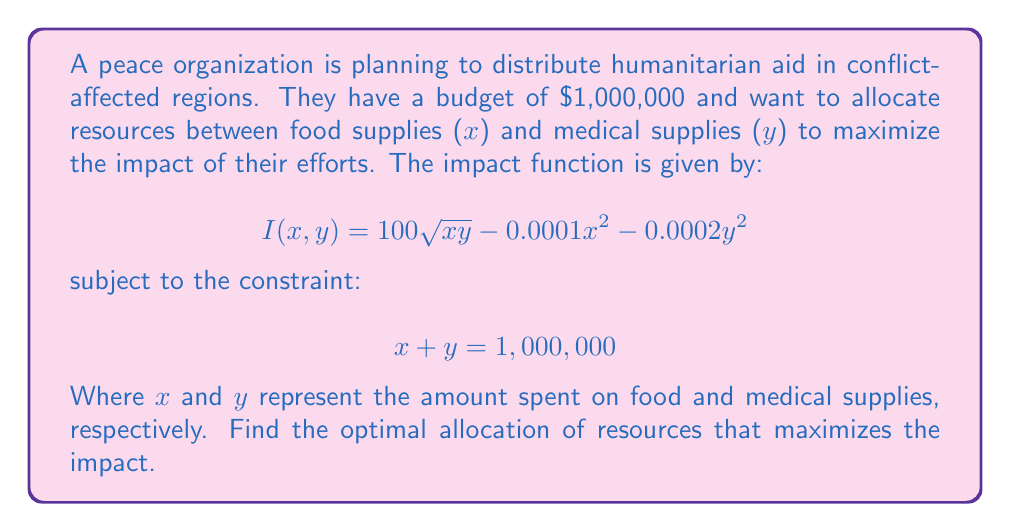Help me with this question. To solve this nonlinear optimization problem, we'll use the method of Lagrange multipliers:

1. Define the Lagrangian function:
   $$L(x,y,\lambda) = 100\sqrt{xy} - 0.0001x^2 - 0.0002y^2 - \lambda(x + y - 1,000,000)$$

2. Take partial derivatives and set them equal to zero:
   $$\frac{\partial L}{\partial x} = \frac{50y}{\sqrt{xy}} - 0.0002x - \lambda = 0$$
   $$\frac{\partial L}{\partial y} = \frac{50x}{\sqrt{xy}} - 0.0004y - \lambda = 0$$
   $$\frac{\partial L}{\partial \lambda} = x + y - 1,000,000 = 0$$

3. From the first two equations:
   $$\frac{50y}{\sqrt{xy}} - 0.0002x = \frac{50x}{\sqrt{xy}} - 0.0004y$$

4. Simplify:
   $$50y - 0.0002x\sqrt{xy} = 50x - 0.0004y\sqrt{xy}$$
   $$50y - 50x = 0.0002x\sqrt{xy} - 0.0004y\sqrt{xy}$$
   $$50(y - x) = 0.0002\sqrt{xy}(x - 2y)$$

5. This implies $y = x$ or $x = 2y$. Given the symmetry of the impact function, $y = x$ is more likely.

6. Substitute $y = x$ into the constraint equation:
   $$x + x = 1,000,000$$
   $$x = 500,000$$

7. Verify that this solution satisfies the original equations and maximizes the impact function.
Answer: $x = y = 500,000$ 